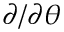Convert formula to latex. <formula><loc_0><loc_0><loc_500><loc_500>\partial / \partial \theta</formula> 